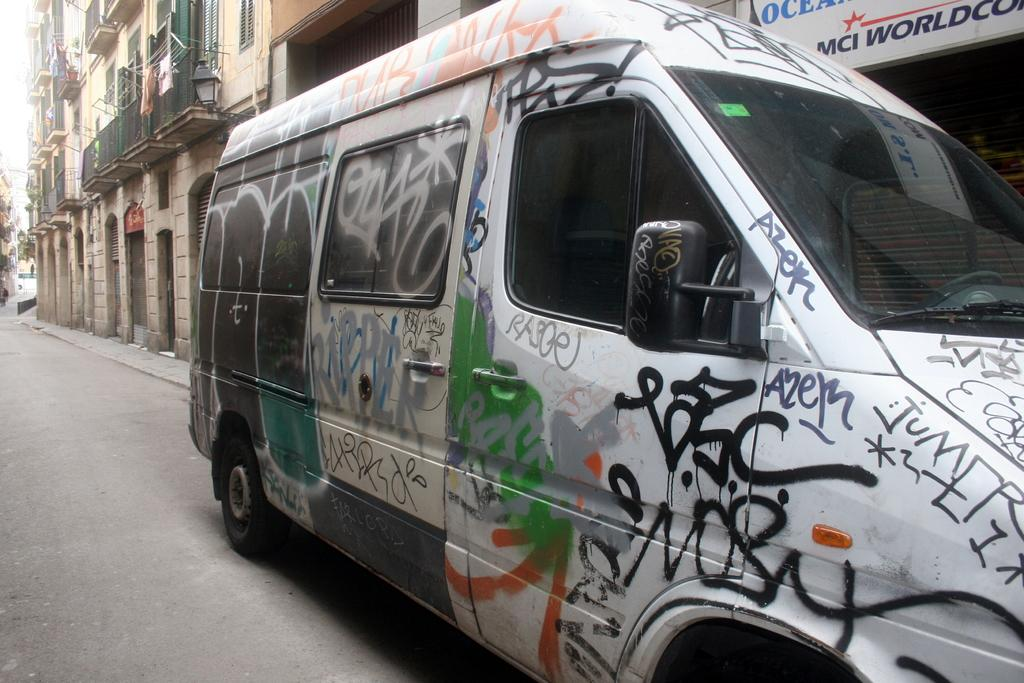What type of vehicle is depicted in the image? There is a vehicle with some painting in the image. What else can be seen in the image besides the vehicle? There are buildings, windows, a board with some text, and the sky visible in the image. Can you describe the vehicle's features? The vehicle has a grille and a light. What is the belief of the vehicle in the image? Vehicles do not have beliefs; they are inanimate objects. --- Facts: 1. There is a person sitting on a chair in the image. 2. The person is holding a book. 3. There is a table in the image. 4. The table has a lamp on it. 5. The background of the image is a room. Absurd Topics: dance, ocean, mountain Conversation: What is the person in the image doing? There is a person sitting on a chair in the image. What is the person holding? The person is holding a book. What is on the table in the image? There is a lamp on the table in the image. What is the setting of the image? The background of the image is a room. Reasoning: Let's think step by step in order to produce the conversation. We start by identifying the main subject in the image, which is the person sitting on a chair. Then, we expand the conversation to include other elements in the image, such as the book, the table, and the lamp. We also describe the setting of the image, which is a room. Each question is designed to elicit a specific detail about the image that is known from the provided facts. Absurd Question/Answer: Can you see any mountains in the image? There are no mountains visible in the image; the background is a room. 